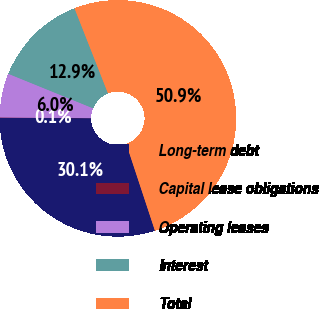Convert chart to OTSL. <chart><loc_0><loc_0><loc_500><loc_500><pie_chart><fcel>Long-term debt<fcel>Capital lease obligations<fcel>Operating leases<fcel>Interest<fcel>Total<nl><fcel>30.14%<fcel>0.06%<fcel>6.03%<fcel>12.88%<fcel>50.89%<nl></chart> 